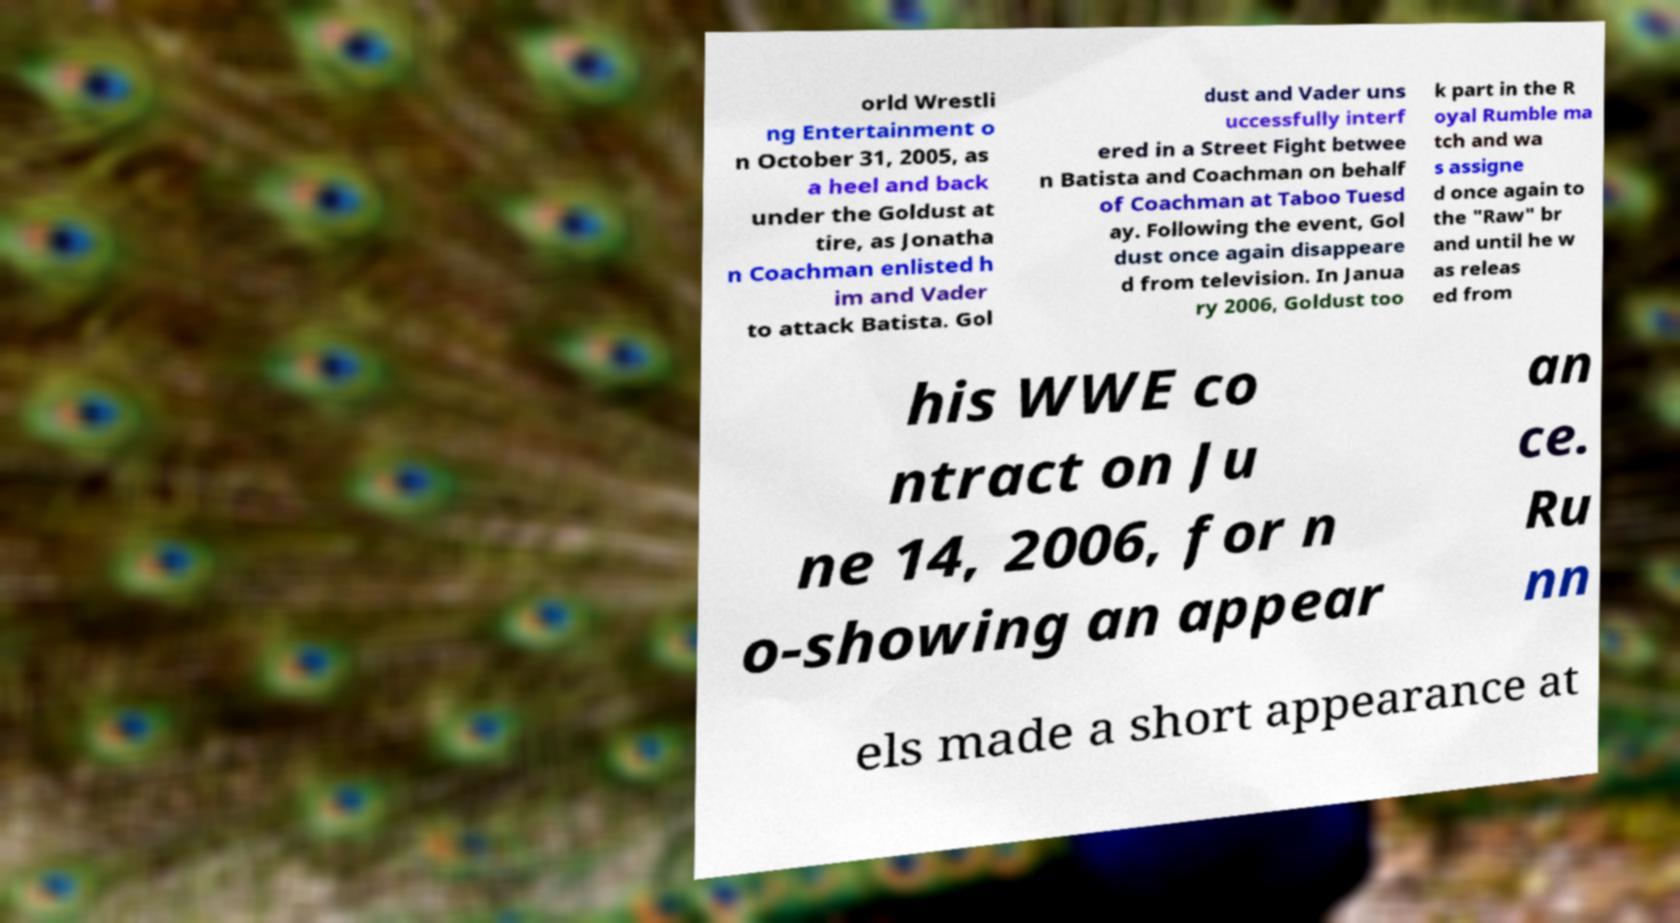Could you extract and type out the text from this image? orld Wrestli ng Entertainment o n October 31, 2005, as a heel and back under the Goldust at tire, as Jonatha n Coachman enlisted h im and Vader to attack Batista. Gol dust and Vader uns uccessfully interf ered in a Street Fight betwee n Batista and Coachman on behalf of Coachman at Taboo Tuesd ay. Following the event, Gol dust once again disappeare d from television. In Janua ry 2006, Goldust too k part in the R oyal Rumble ma tch and wa s assigne d once again to the "Raw" br and until he w as releas ed from his WWE co ntract on Ju ne 14, 2006, for n o-showing an appear an ce. Ru nn els made a short appearance at 